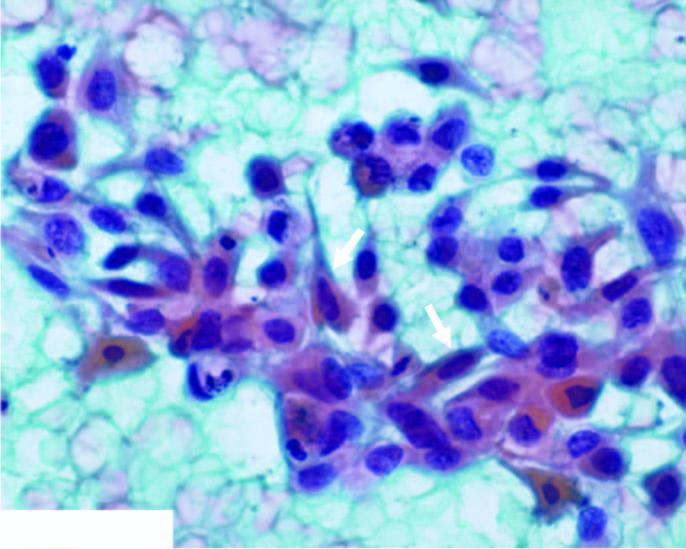do the malignant epithelial cells have anisonucleosis with irregular nuclear chromatin with prominent nucleoli?
Answer the question using a single word or phrase. Yes 